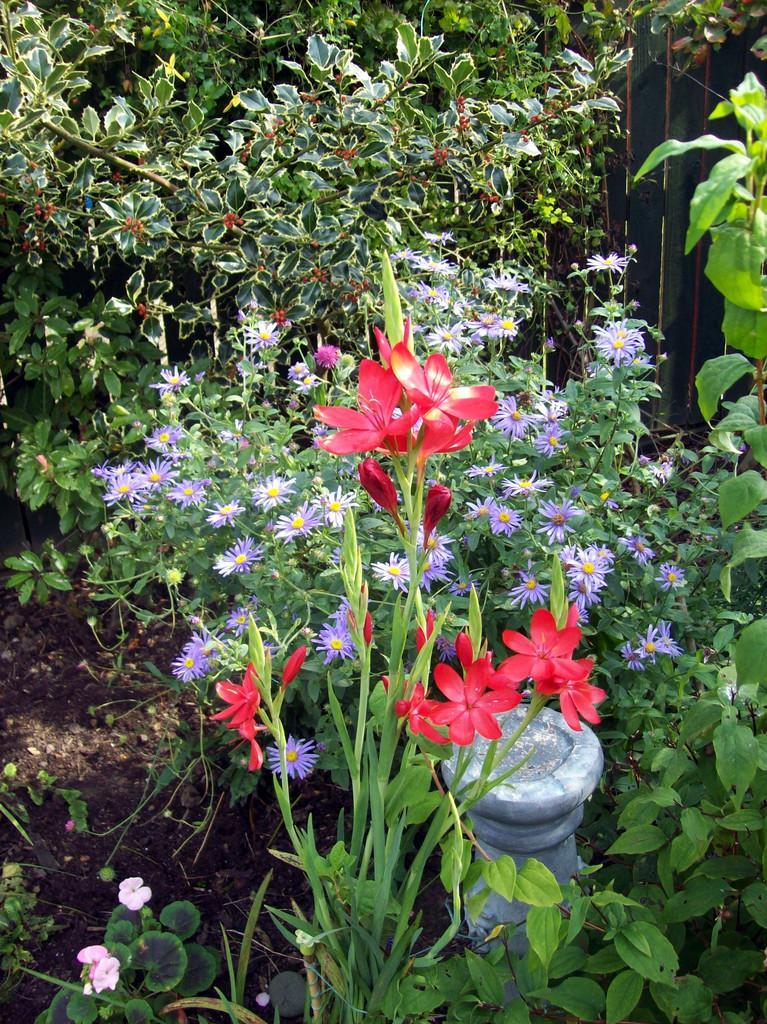How would you summarize this image in a sentence or two? In the image there are plants. There are few plants with flowers. In between the plants there is an object. 